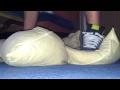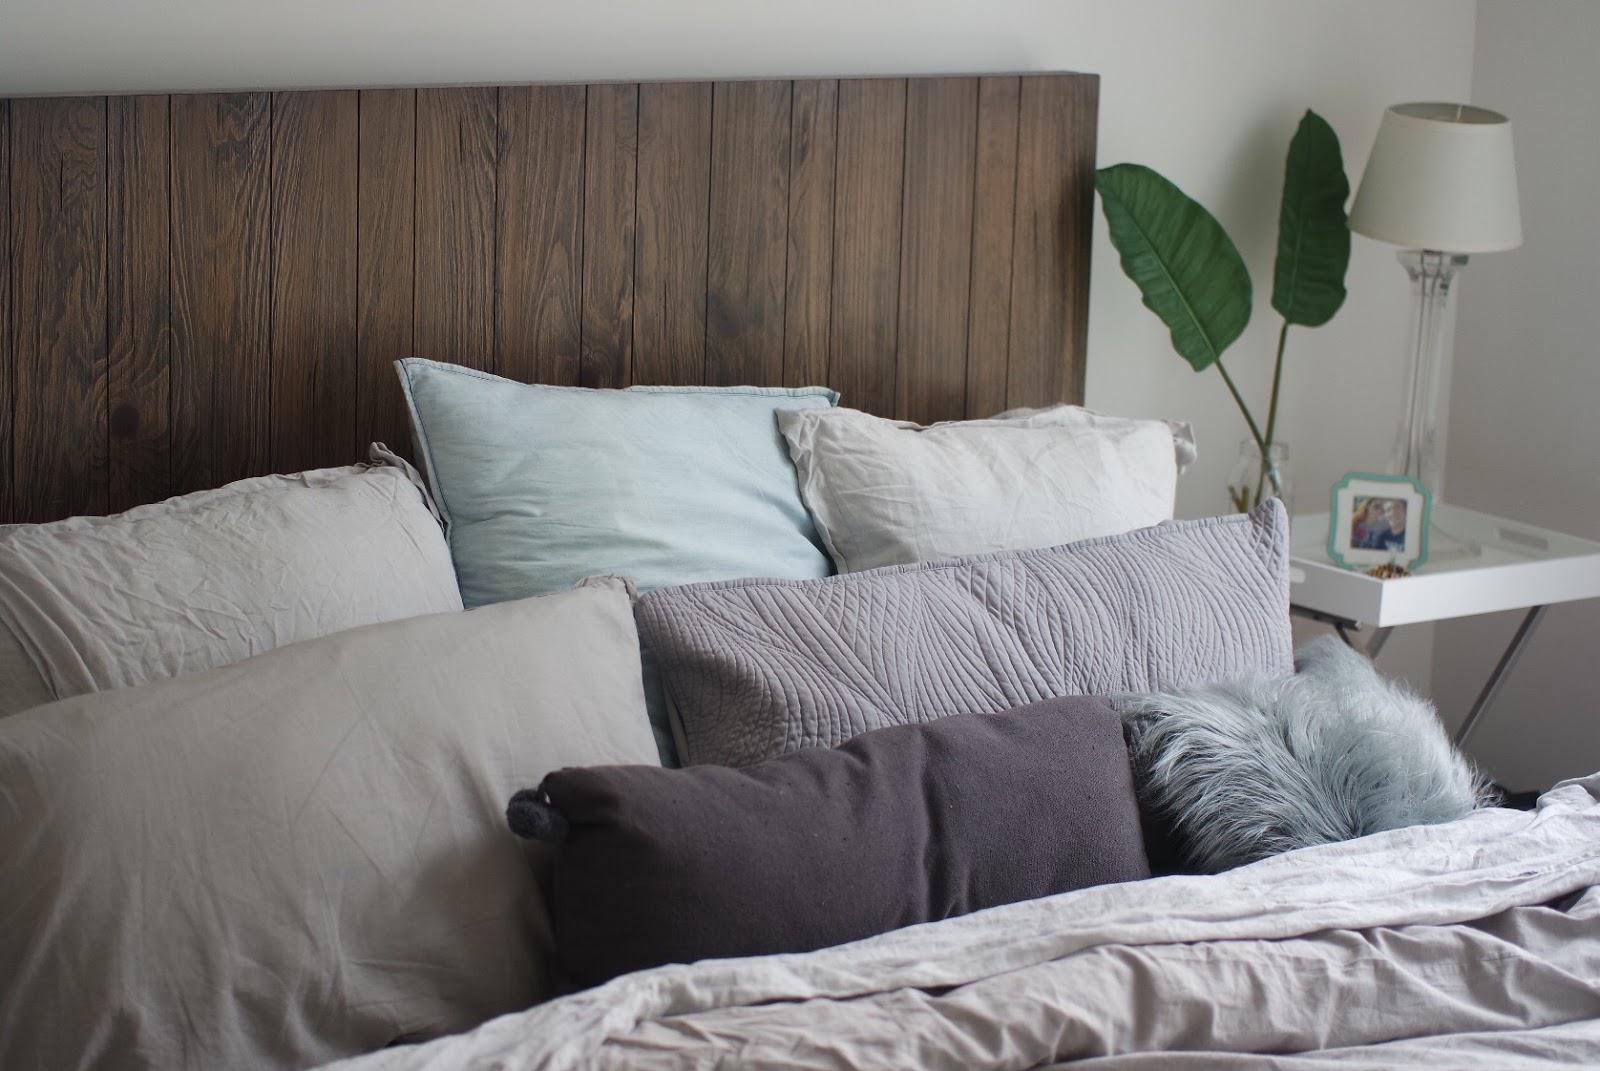The first image is the image on the left, the second image is the image on the right. Given the left and right images, does the statement "A image shows a pillow with a 3D embellishment." hold true? Answer yes or no. No. The first image is the image on the left, the second image is the image on the right. Considering the images on both sides, is "There are at least six pillows in the image on the right" valid? Answer yes or no. Yes. 